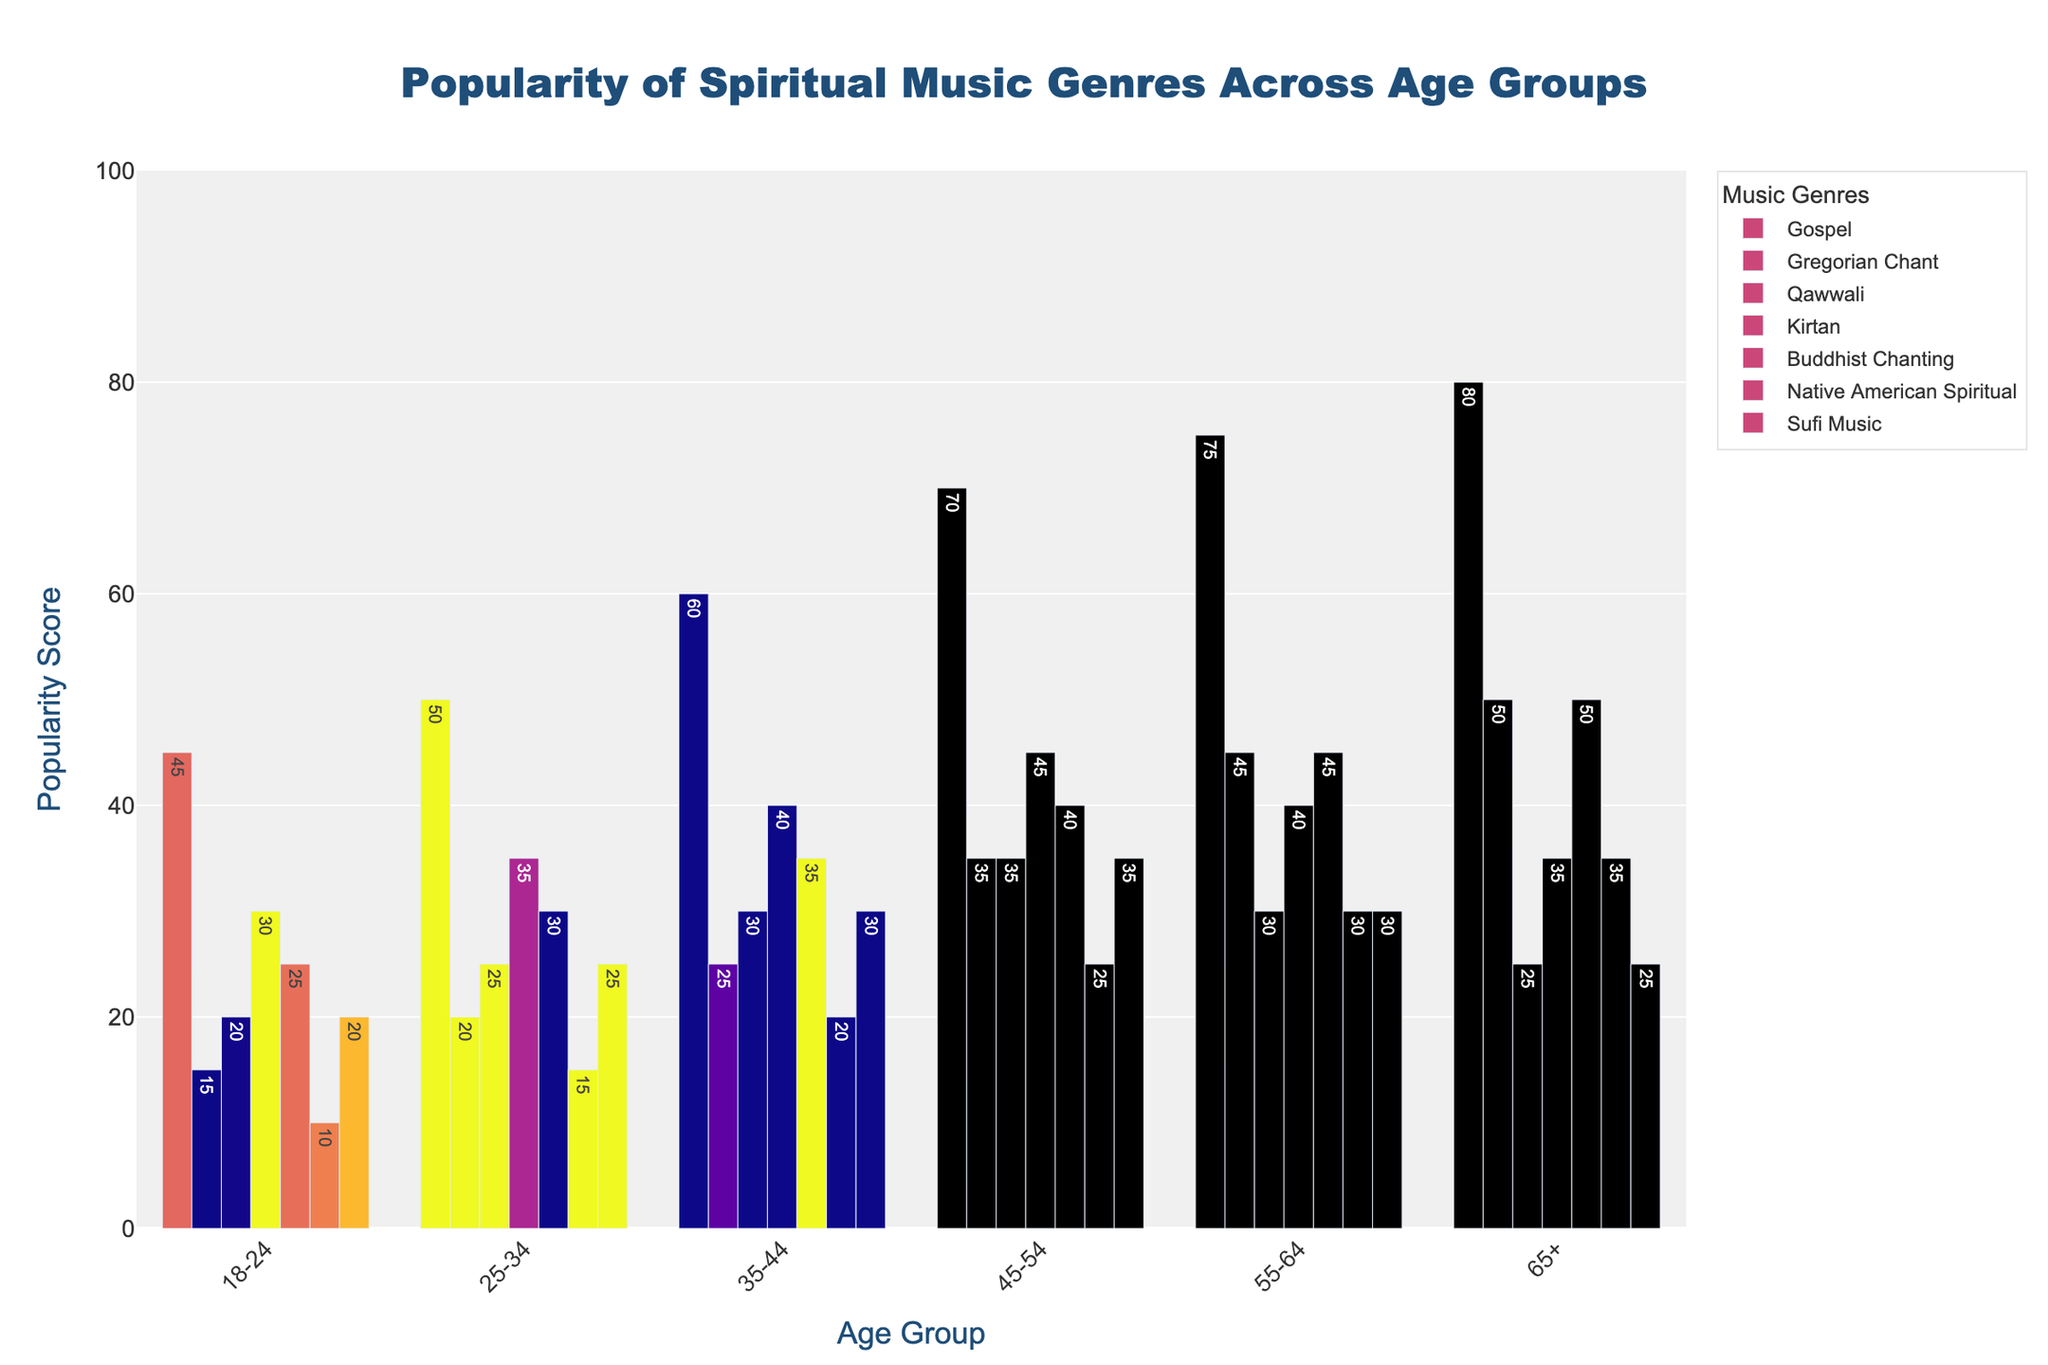What is the most popular spiritual music genre among the 18-24 age group? By inspecting the bar heights for the age group 18-24, Gospel has the highest bar indicating the highest popularity score of 45.
Answer: Gospel What is the least popular genre among the 65+ age group? By looking at the bars for the 65+ group, the bar for Qawwali is the shortest with a popularity score of 25.
Answer: Qawwali Which age group has the highest popularity score for Gregorian Chant? Looking at the bars representing Gregorian Chant across all age groups, the bar for the 65+ group is the highest with a score of 50.
Answer: 65+ Compare the popularity of Kirtan between the 25-34 and 45-54 age groups. Which age group prefers it more? From the bars representing Kirtan, the 45-54 age group has a higher score (45) compared to the 25-34 age group (35).
Answer: 45-54 What is the total popularity score for Sufi Music across all age groups? Summing the popularity scores of Sufi Music: 20 + 25 + 30 + 35 + 30 + 25 = 165.
Answer: 165 Which spiritual music genre has the highest variation in popularity among different age groups? By inspecting the bars, Gospel shows the highest range from 45 (18-24) to 80 (65+), the broadest variation.
Answer: Gospel What is the average popularity score for Native American Spiritual music across all age groups? Summing the scores for Native American Spiritual: 10 + 15 + 20 + 25 + 30 + 35 = 135, then dividing by 6 age groups gives an average of 22.5.
Answer: 22.5 Is the popularity of Buddhist Chanting increasing or decreasing with age? Observing the bars for Buddhist Chanting, the popularity score increases with each age group: 25, 30, 35, 40, 45, 50.
Answer: Increasing Calculate the difference in popularity scores for Gospel music between the 55-64 and 18-24 age groups. The popularity score for Gospel in 55-64 is 75, and for 18-24 is 45. The difference is 75 - 45 = 30.
Answer: 30 Which age group has the lowest total popularity score across all genres? Sum the popularity scores for each age group: 
18-24: 45+15+20+30+25+10+20 = 165
25-34: 50+20+25+35+30+15+25 = 200
35-44: 60+25+30+40+35+20+30 = 240
45-54: 70+35+35+45+40+25+35 = 285
55-64: 75+45+30+40+45+30+30 = 295
65+: 80+50+25+35+50+35+25 = 300
The group 18-24 has the lowest total score of 165.
Answer: 18-24 